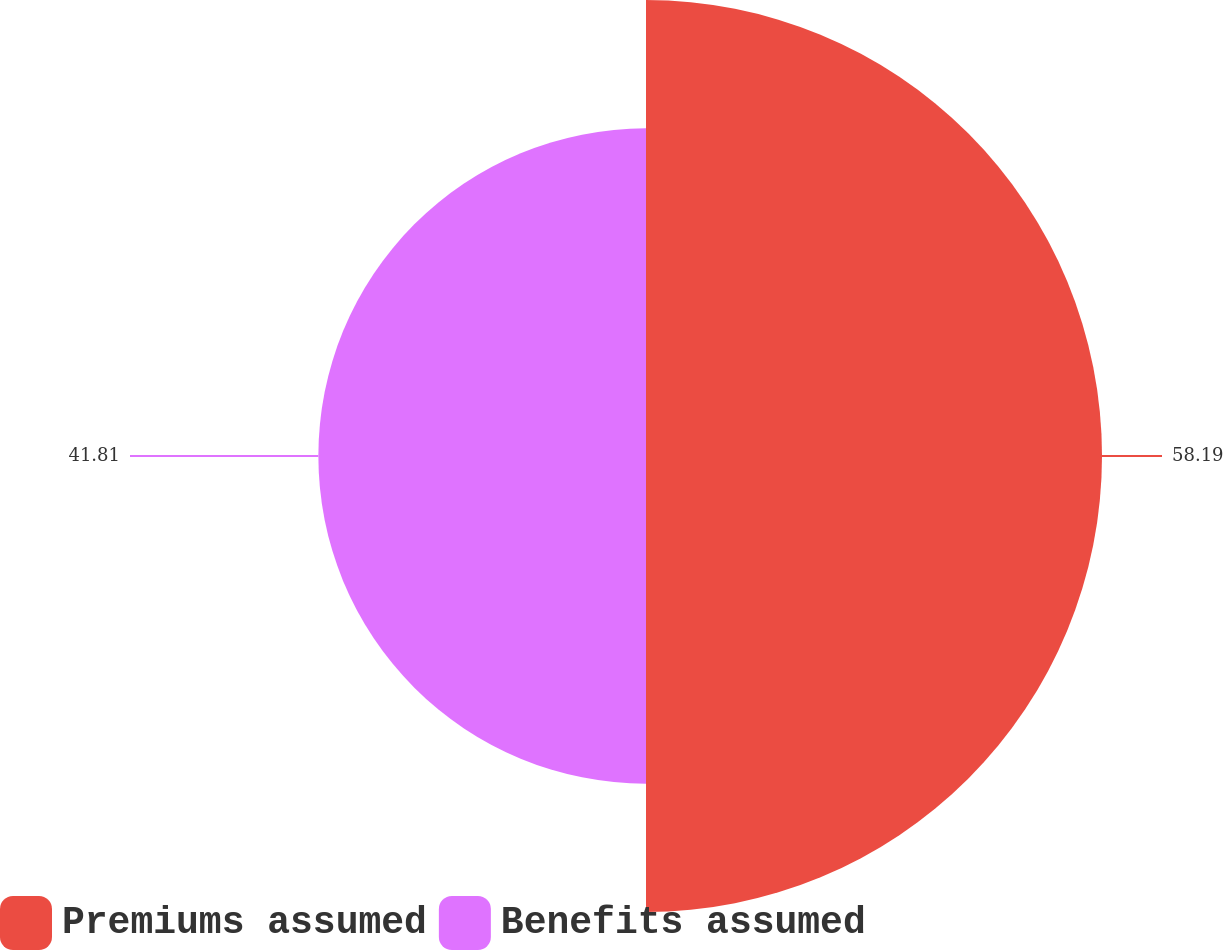Convert chart to OTSL. <chart><loc_0><loc_0><loc_500><loc_500><pie_chart><fcel>Premiums assumed<fcel>Benefits assumed<nl><fcel>58.19%<fcel>41.81%<nl></chart> 